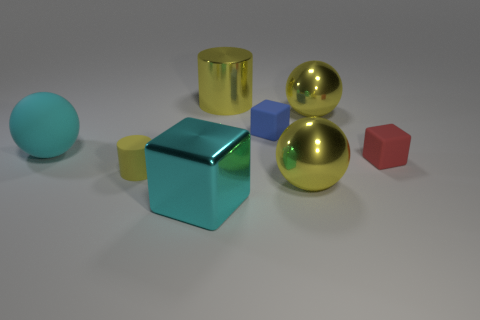Add 1 large gray cylinders. How many objects exist? 9 Subtract all cubes. How many objects are left? 5 Add 5 big brown matte cylinders. How many big brown matte cylinders exist? 5 Subtract 0 blue balls. How many objects are left? 8 Subtract all blue shiny cylinders. Subtract all cyan rubber things. How many objects are left? 7 Add 4 metal balls. How many metal balls are left? 6 